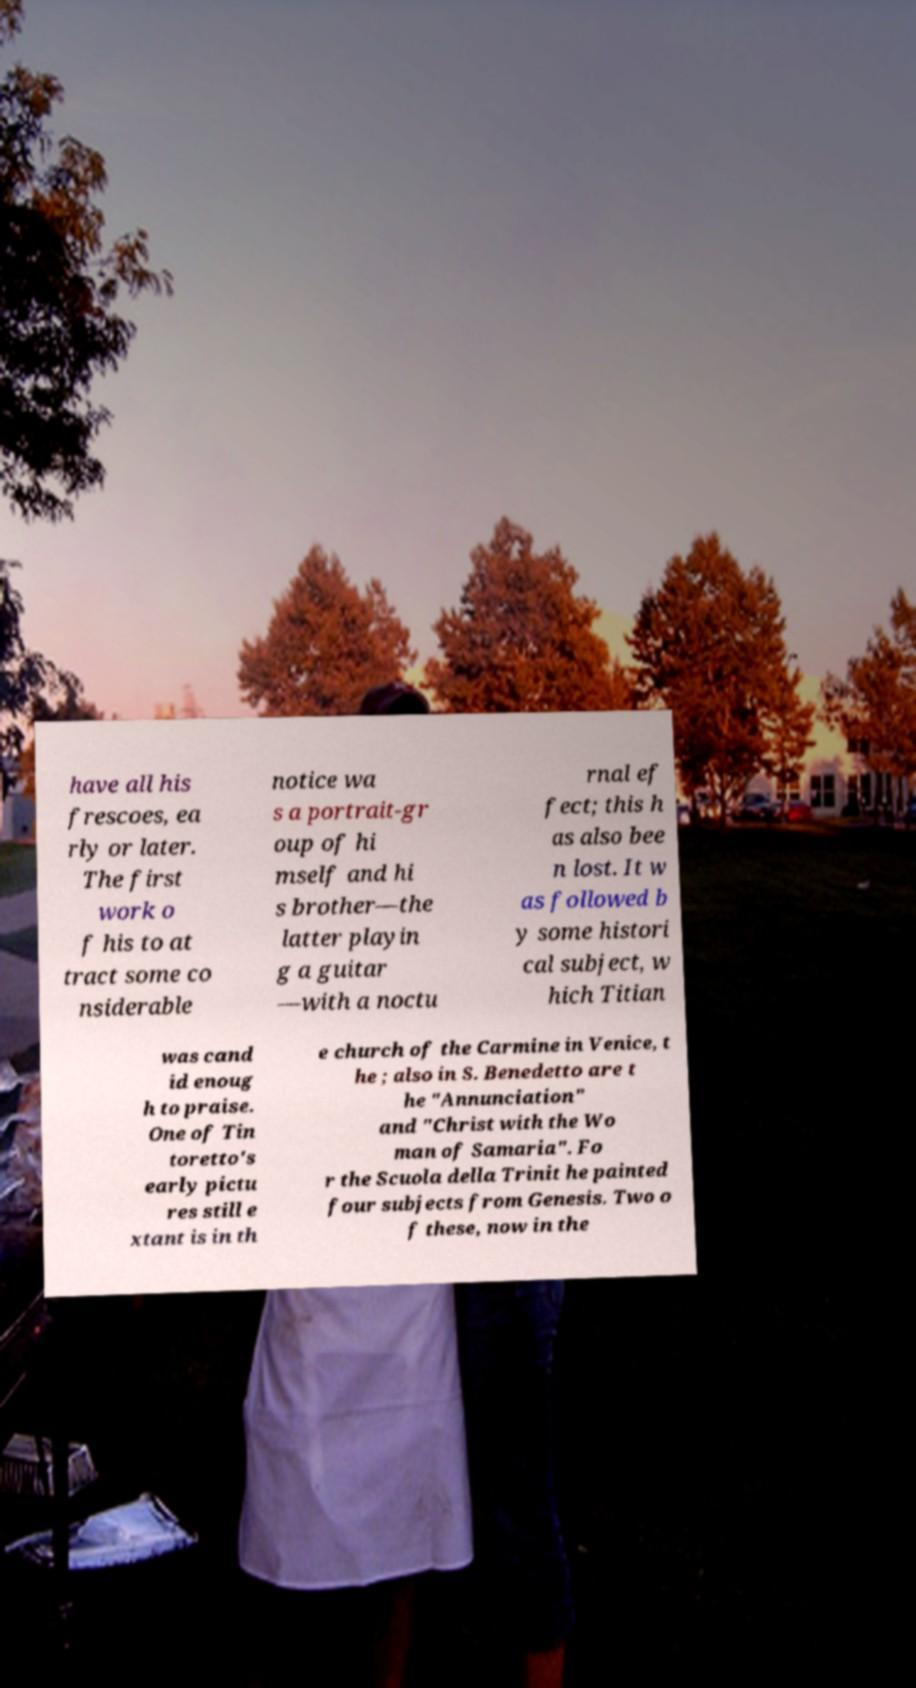Can you read and provide the text displayed in the image?This photo seems to have some interesting text. Can you extract and type it out for me? have all his frescoes, ea rly or later. The first work o f his to at tract some co nsiderable notice wa s a portrait-gr oup of hi mself and hi s brother—the latter playin g a guitar —with a noctu rnal ef fect; this h as also bee n lost. It w as followed b y some histori cal subject, w hich Titian was cand id enoug h to praise. One of Tin toretto's early pictu res still e xtant is in th e church of the Carmine in Venice, t he ; also in S. Benedetto are t he "Annunciation" and "Christ with the Wo man of Samaria". Fo r the Scuola della Trinit he painted four subjects from Genesis. Two o f these, now in the 